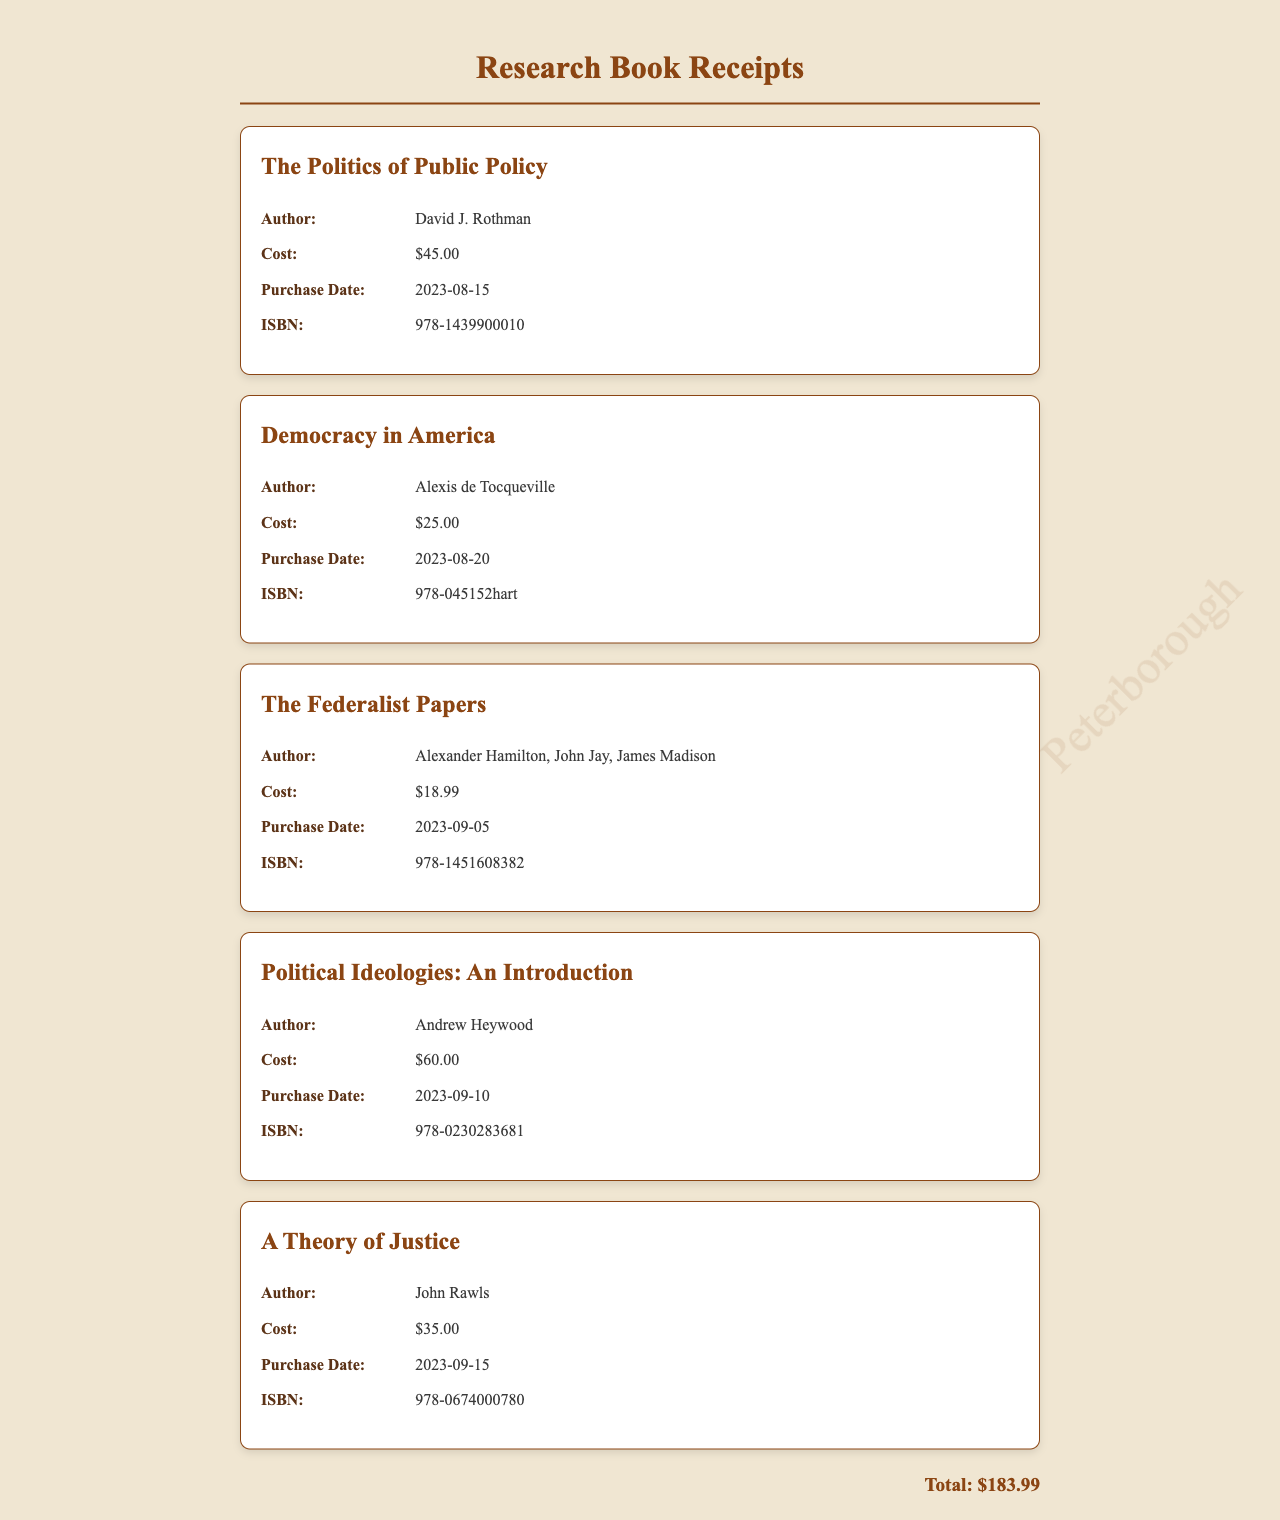what is the total cost of the books? The total cost is listed at the bottom of the document and includes all individual book costs added together, resulting in $183.99.
Answer: $183.99 who is the author of "A Theory of Justice"? The author is specified under the title in the document, which is John Rawls.
Answer: John Rawls when was "Democracy in America" purchased? The purchase date for this book is noted next to the title, which is 2023-08-20.
Answer: 2023-08-20 what is the ISBN of "Political Ideologies: An Introduction"? The ISBN is provided in the details section of the book, which is 978-0230283681.
Answer: 978-0230283681 which book has the highest cost? The highest cost is indicated in the price of the book, which is $60.00 for "Political Ideologies: An Introduction."
Answer: Political Ideologies: An Introduction who are the authors of "The Federalist Papers"? The authors are listed under the title in the document as Alexander Hamilton, John Jay, and James Madison.
Answer: Alexander Hamilton, John Jay, James Madison what is the purchase date of "The Politics of Public Policy"? The purchase date can be found in the receipt details, which is 2023-08-15.
Answer: 2023-08-15 how many books are listed in total? The total number of books can be counted from the receipts presented, which amounts to five books.
Answer: 5 what color is used for the title in the receipts? The color specified for the title is noted in the CSS section of the document, which is #8b4513.
Answer: #8b4513 